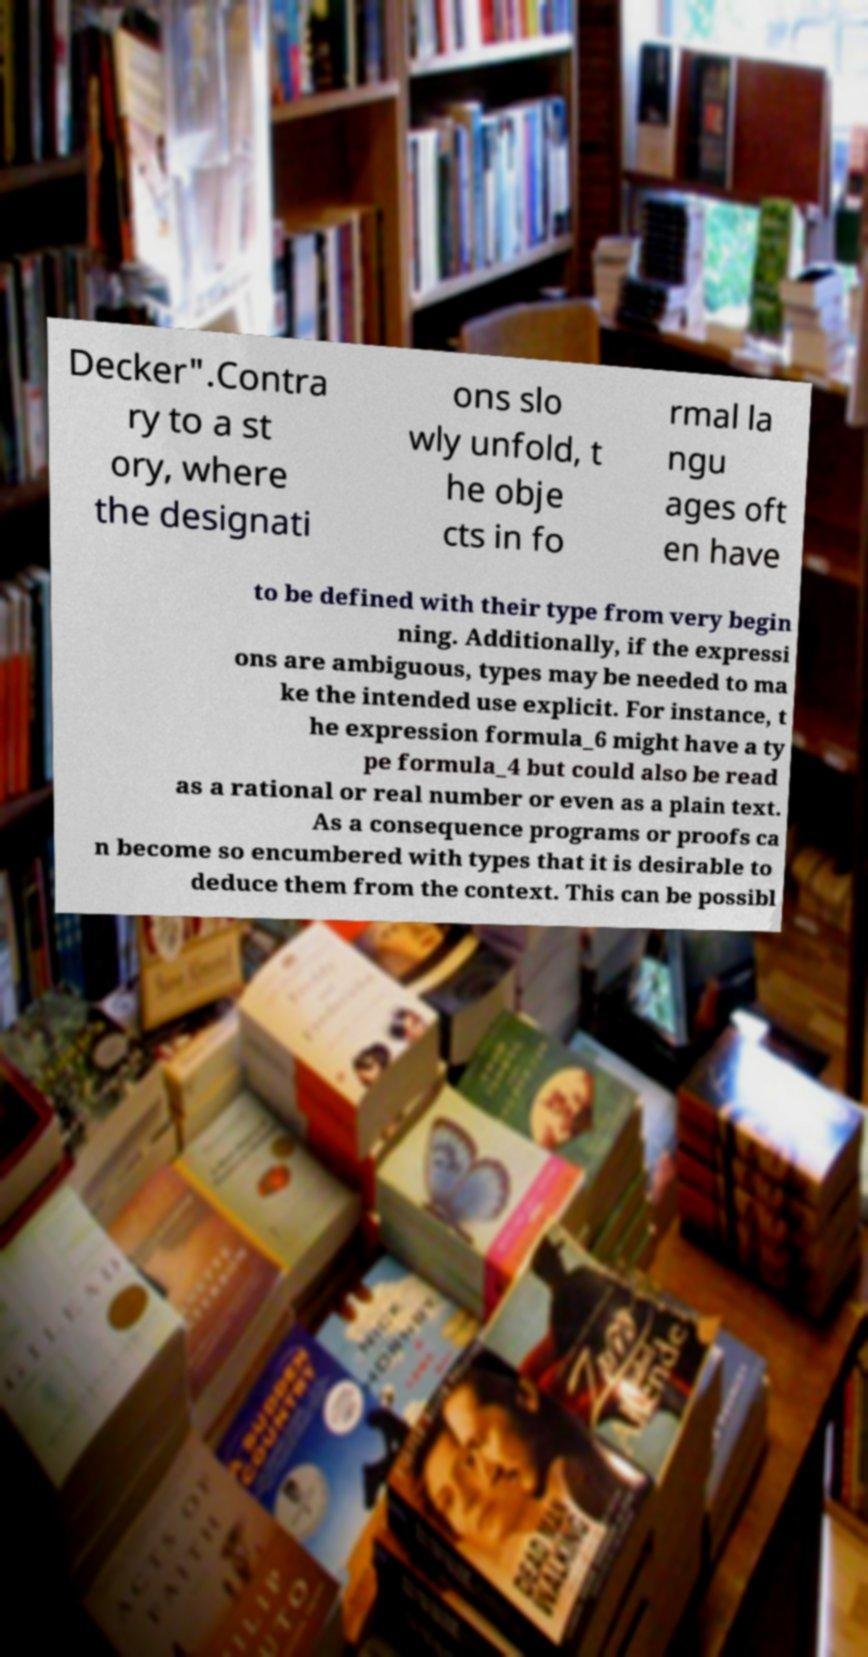Can you accurately transcribe the text from the provided image for me? Decker".Contra ry to a st ory, where the designati ons slo wly unfold, t he obje cts in fo rmal la ngu ages oft en have to be defined with their type from very begin ning. Additionally, if the expressi ons are ambiguous, types may be needed to ma ke the intended use explicit. For instance, t he expression formula_6 might have a ty pe formula_4 but could also be read as a rational or real number or even as a plain text. As a consequence programs or proofs ca n become so encumbered with types that it is desirable to deduce them from the context. This can be possibl 